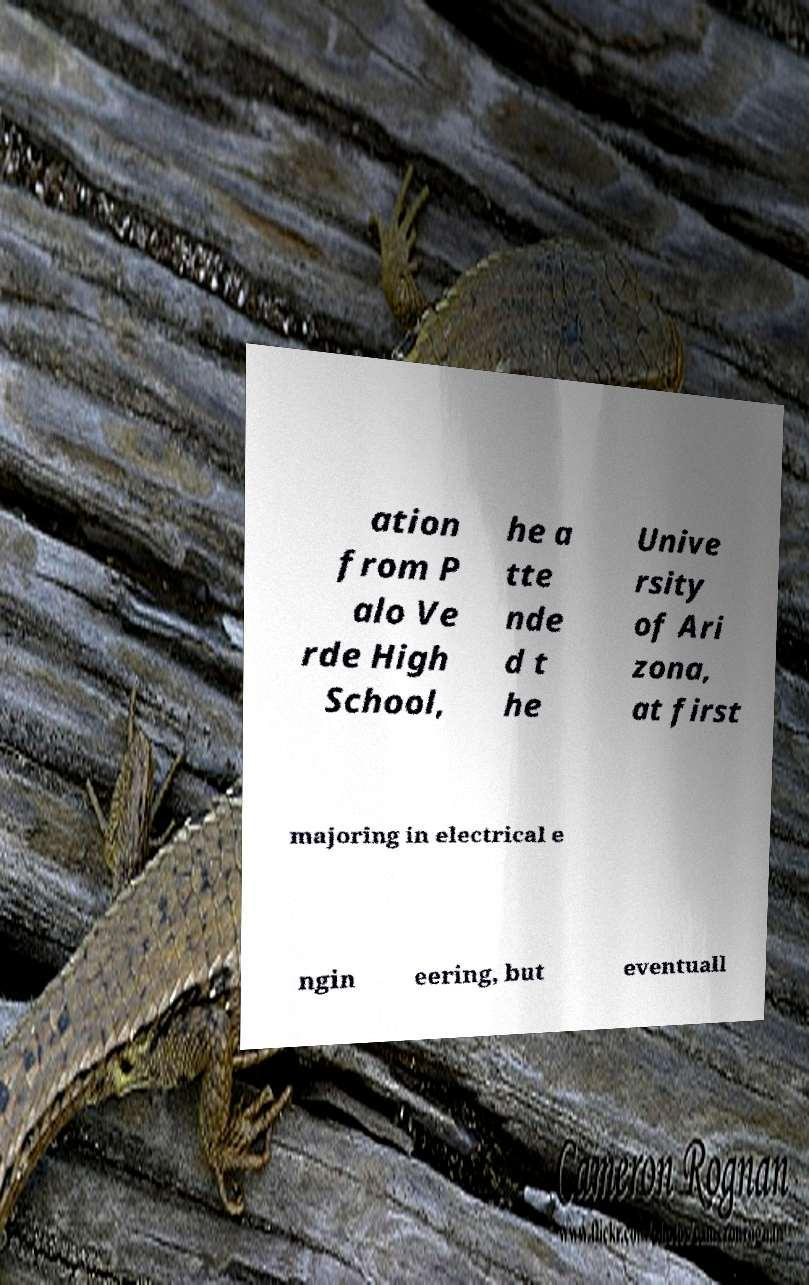Can you read and provide the text displayed in the image?This photo seems to have some interesting text. Can you extract and type it out for me? ation from P alo Ve rde High School, he a tte nde d t he Unive rsity of Ari zona, at first majoring in electrical e ngin eering, but eventuall 